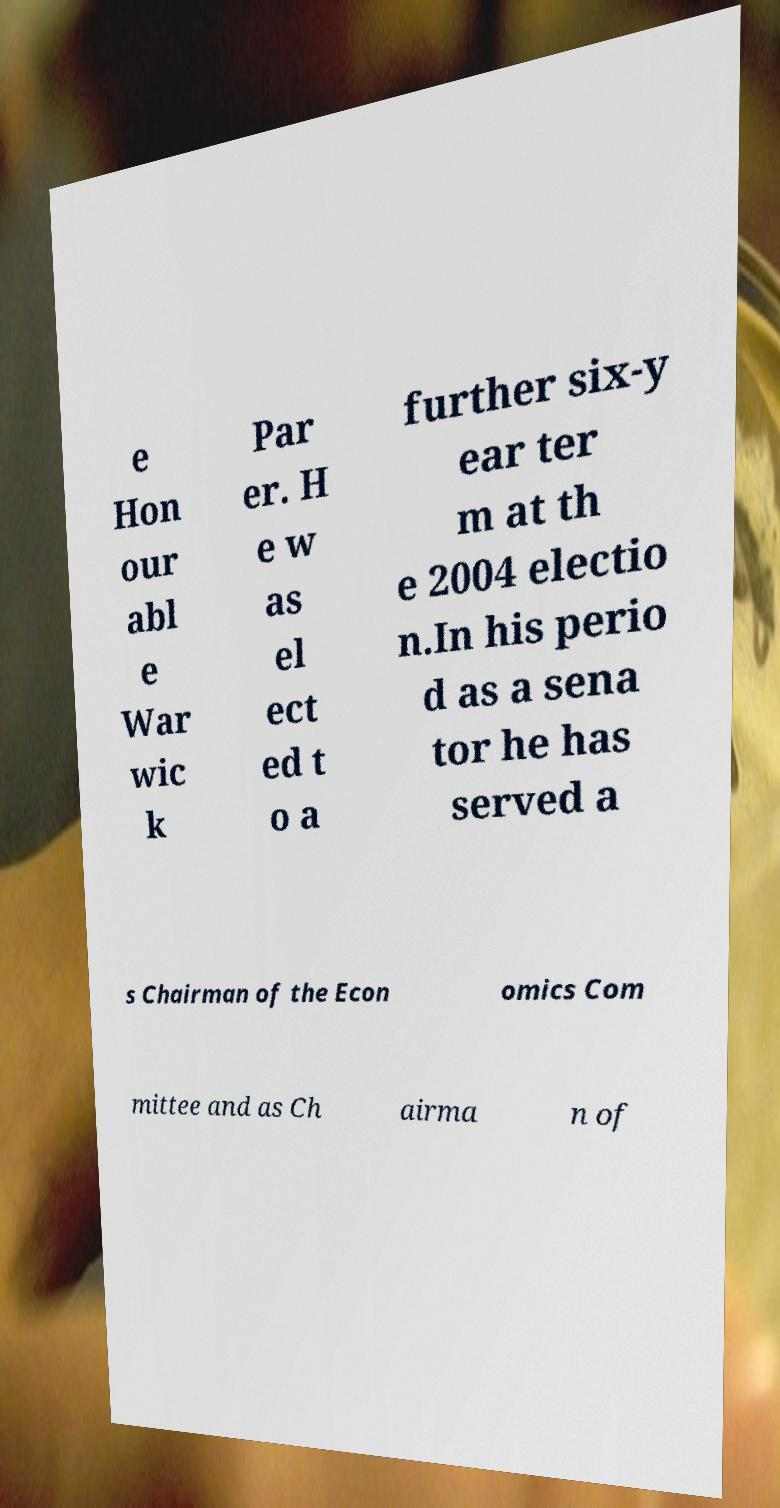Can you accurately transcribe the text from the provided image for me? e Hon our abl e War wic k Par er. H e w as el ect ed t o a further six-y ear ter m at th e 2004 electio n.In his perio d as a sena tor he has served a s Chairman of the Econ omics Com mittee and as Ch airma n of 